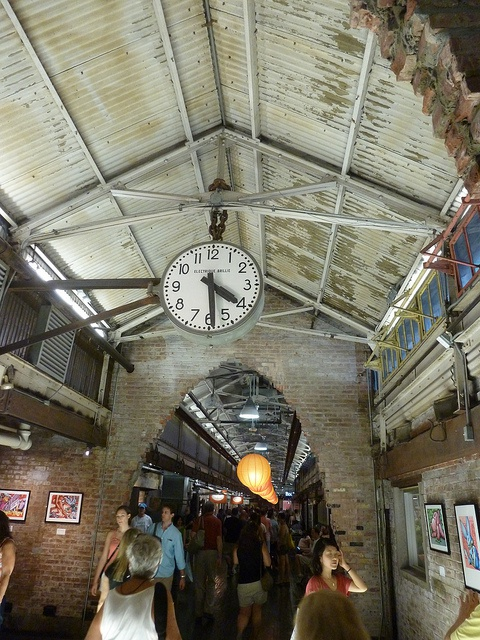Describe the objects in this image and their specific colors. I can see clock in darkgray, lightgray, gray, and black tones, people in darkgray, black, lightgray, and gray tones, people in darkgray, black, gray, and darkgreen tones, people in darkgray, black, darkgreen, maroon, and gray tones, and people in darkgray, black, and gray tones in this image. 